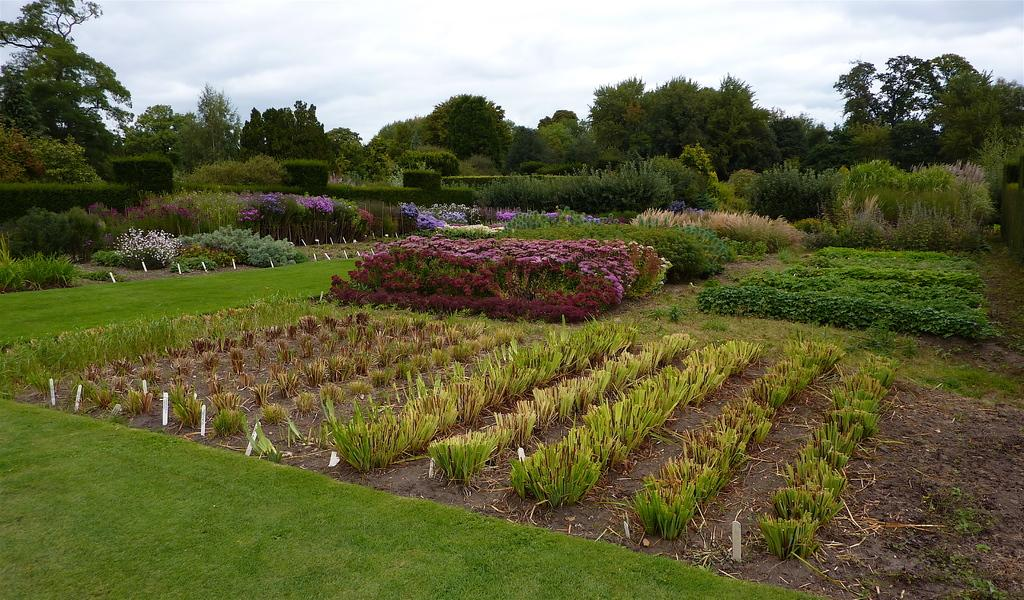What type of outdoor space is shown in the image? The image depicts a garden. What types of vegetation can be seen in the garden? There are plants, grass, flowers, shrubs, and trees visible in the garden. Can you see a donkey in the garden? There is no donkey present in the image. 